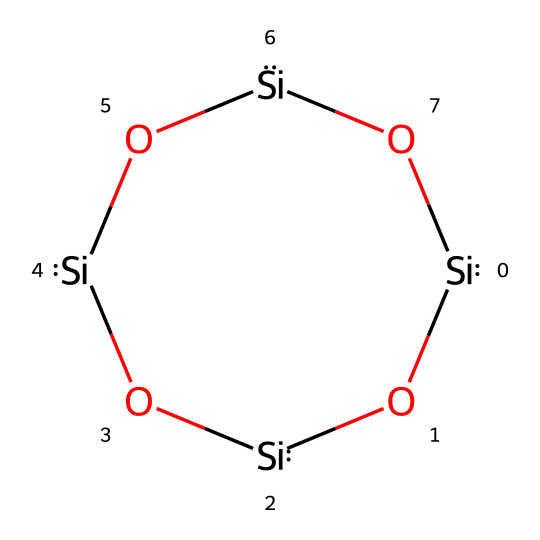how many silicon atoms are present in this chemical? By analyzing the SMILES representation, we notice that the structure begins with [Si] and each silicon atom is represented individually. The sequence repeats several times, indicating each silicon atom's presence. Counting these will yield the total number.
Answer: four how many oxygen atoms are present in this chemical? In the SMILES, the presence of oxygen atoms is indicated by the [O] notation. By counting the occurrences of [O] in the sequence, we can determine the total number of oxygen atoms present.
Answer: four what type of bonding is primarily present in this chemical structure? The structure consists of a series of silicon and oxygen atoms linked together, which indicates a silicate structure typical of ceramics. The primary bonds in this compound are covalent, as silicon and oxygen share electrons in a strong bond.
Answer: covalent is this ceramic composition likely to provide good heat resistance? Yes, ceramics are known for their high thermal stability and resistance to heat. The silicate structure with silicon and oxygen aligns with properties that contribute to good heat resistance.
Answer: yes what is the primary structural unit of this ceramic? The primary structural unit in the given SMILES is the chain of alternating silicon and oxygen atoms, which forms a silicate network. This is characteristic of many ceramic materials.
Answer: silicate network how does the silicon-oxygen bond contribute to the stability of the ceramic? The silicon-oxygen bond is very strong due to its covalent nature, contributing to the thermal and mechanical stability of the ceramic material. This stability under high temperatures is crucial for engine components.
Answer: strong bond stability 